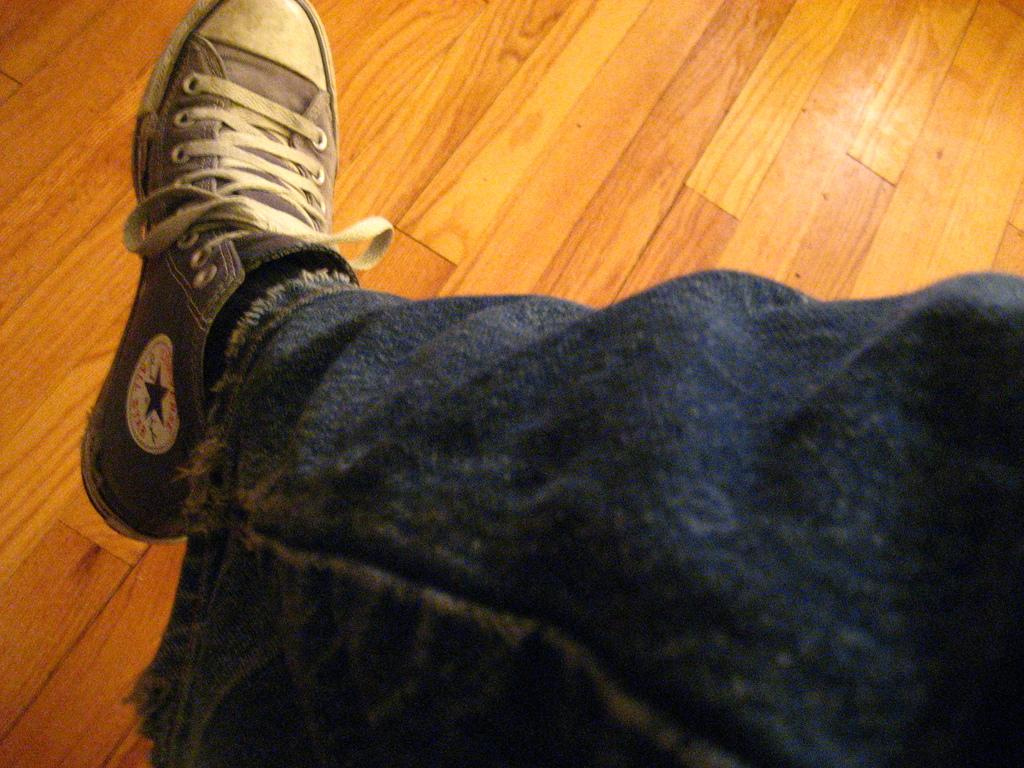What part of a person can be seen in the image? There is a leg of a person in the image. What type of footwear is the person wearing? The person is wearing a shoe. What type of flooring is visible in the image? There is a wooden floor in the image. What is the rate of the iron being used by the person in the image? There is no iron present in the image, and therefore no rate can be determined. 